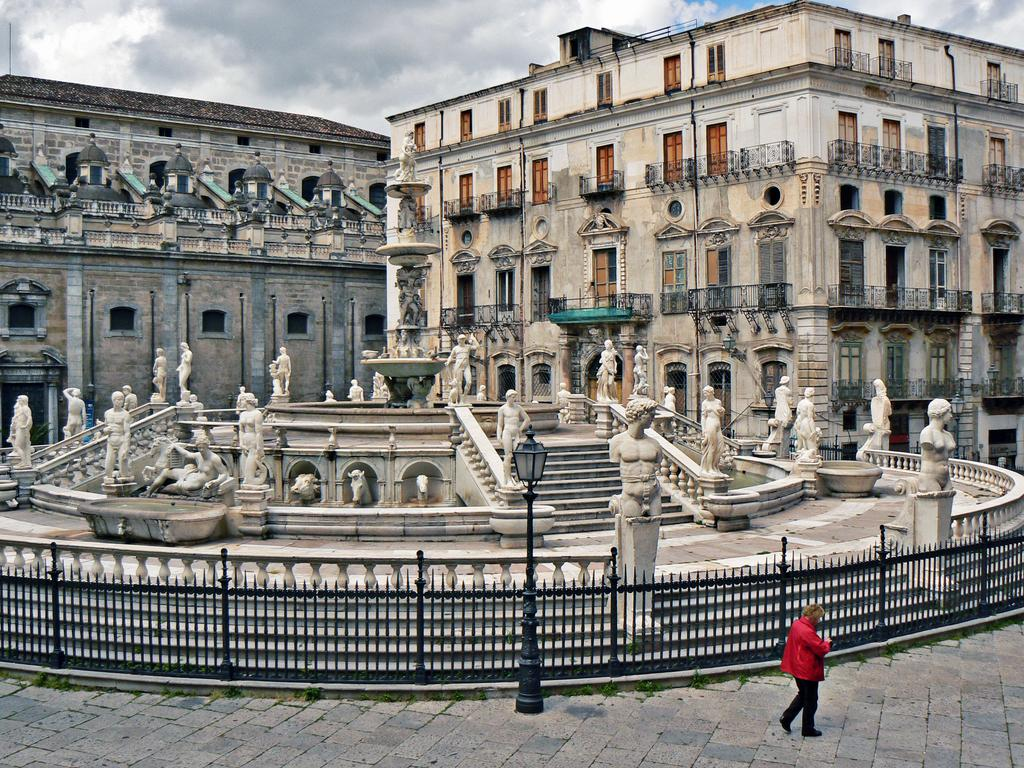What is the main subject in the image? There is a person standing in the image. What other objects or structures can be seen in the image? There are sculptures, iron grills, poles, lights, and buildings visible in the image. What is the background of the image? The sky is visible in the background of the image. How many dogs are present in the image? There are no dogs present in the image. What type of shoe is the person wearing in the image? The image does not show the person's shoes, so it cannot be determined what type of shoe they are wearing. 